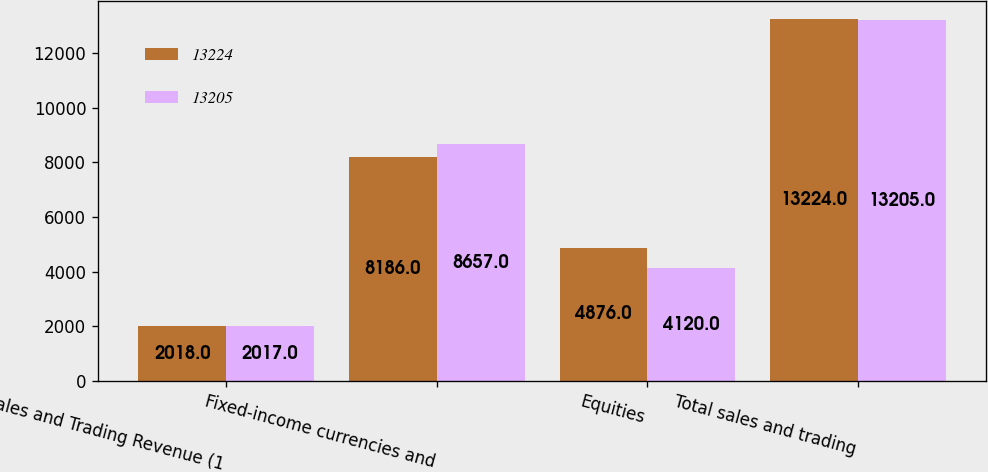Convert chart to OTSL. <chart><loc_0><loc_0><loc_500><loc_500><stacked_bar_chart><ecel><fcel>Sales and Trading Revenue (1<fcel>Fixed-income currencies and<fcel>Equities<fcel>Total sales and trading<nl><fcel>13224<fcel>2018<fcel>8186<fcel>4876<fcel>13224<nl><fcel>13205<fcel>2017<fcel>8657<fcel>4120<fcel>13205<nl></chart> 